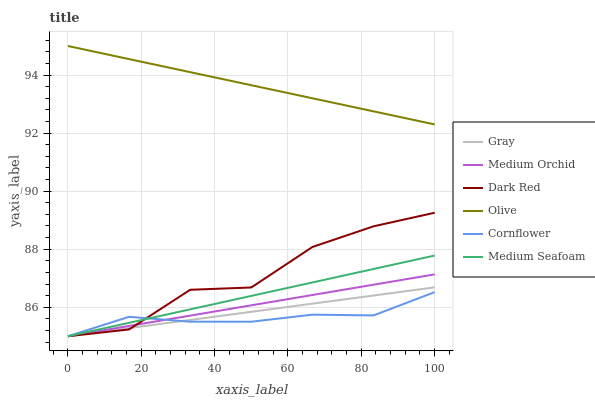Does Cornflower have the minimum area under the curve?
Answer yes or no. Yes. Does Olive have the maximum area under the curve?
Answer yes or no. Yes. Does Dark Red have the minimum area under the curve?
Answer yes or no. No. Does Dark Red have the maximum area under the curve?
Answer yes or no. No. Is Olive the smoothest?
Answer yes or no. Yes. Is Dark Red the roughest?
Answer yes or no. Yes. Is Cornflower the smoothest?
Answer yes or no. No. Is Cornflower the roughest?
Answer yes or no. No. Does Gray have the lowest value?
Answer yes or no. Yes. Does Olive have the lowest value?
Answer yes or no. No. Does Olive have the highest value?
Answer yes or no. Yes. Does Dark Red have the highest value?
Answer yes or no. No. Is Dark Red less than Olive?
Answer yes or no. Yes. Is Olive greater than Gray?
Answer yes or no. Yes. Does Medium Seafoam intersect Dark Red?
Answer yes or no. Yes. Is Medium Seafoam less than Dark Red?
Answer yes or no. No. Is Medium Seafoam greater than Dark Red?
Answer yes or no. No. Does Dark Red intersect Olive?
Answer yes or no. No. 